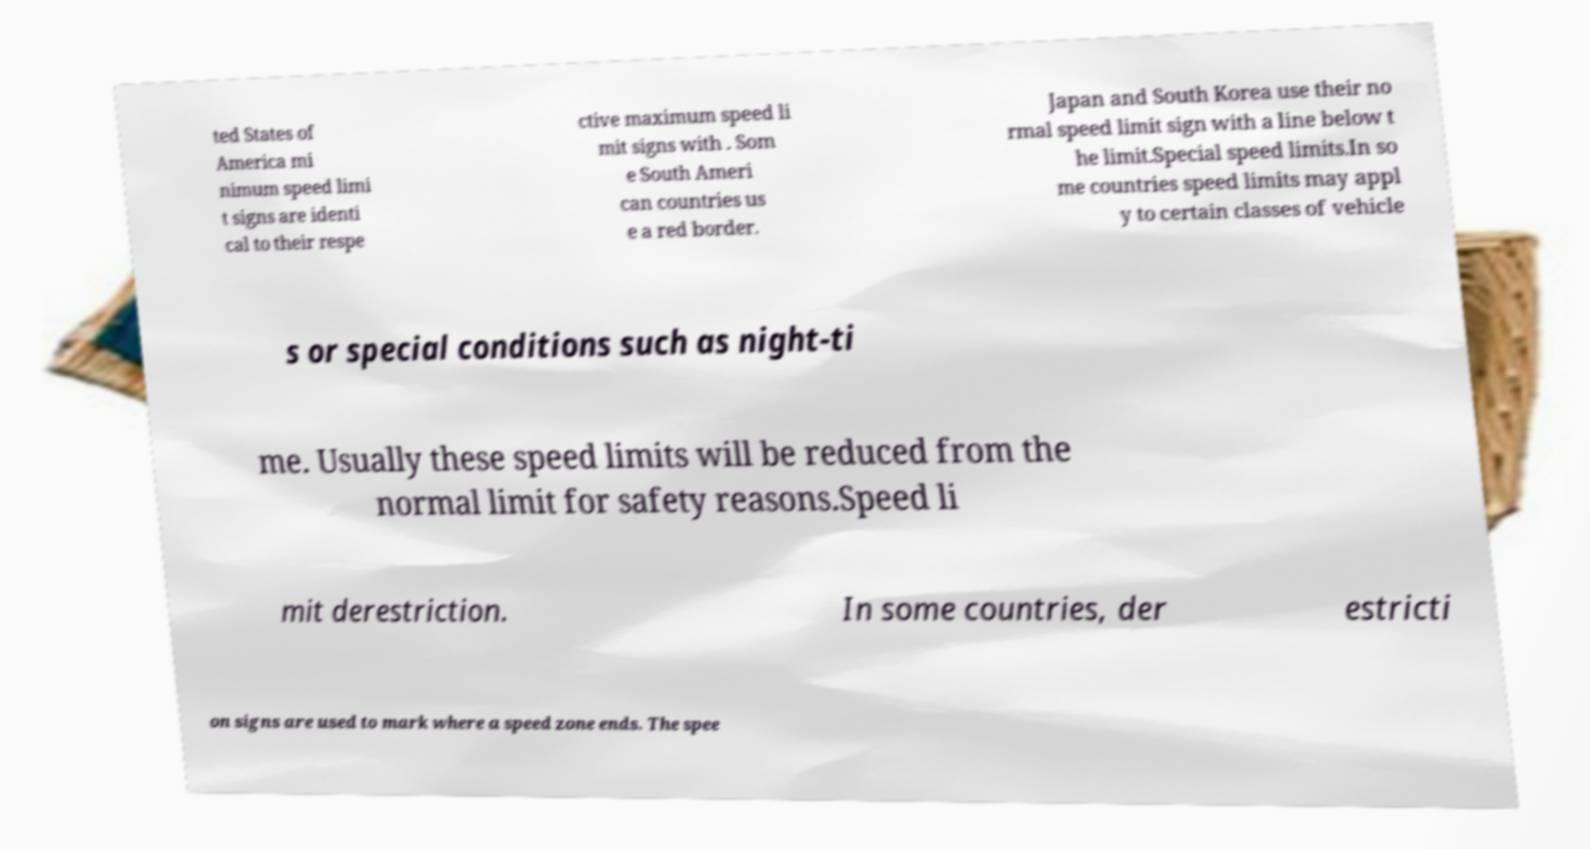I need the written content from this picture converted into text. Can you do that? ted States of America mi nimum speed limi t signs are identi cal to their respe ctive maximum speed li mit signs with . Som e South Ameri can countries us e a red border. Japan and South Korea use their no rmal speed limit sign with a line below t he limit.Special speed limits.In so me countries speed limits may appl y to certain classes of vehicle s or special conditions such as night-ti me. Usually these speed limits will be reduced from the normal limit for safety reasons.Speed li mit derestriction. In some countries, der estricti on signs are used to mark where a speed zone ends. The spee 